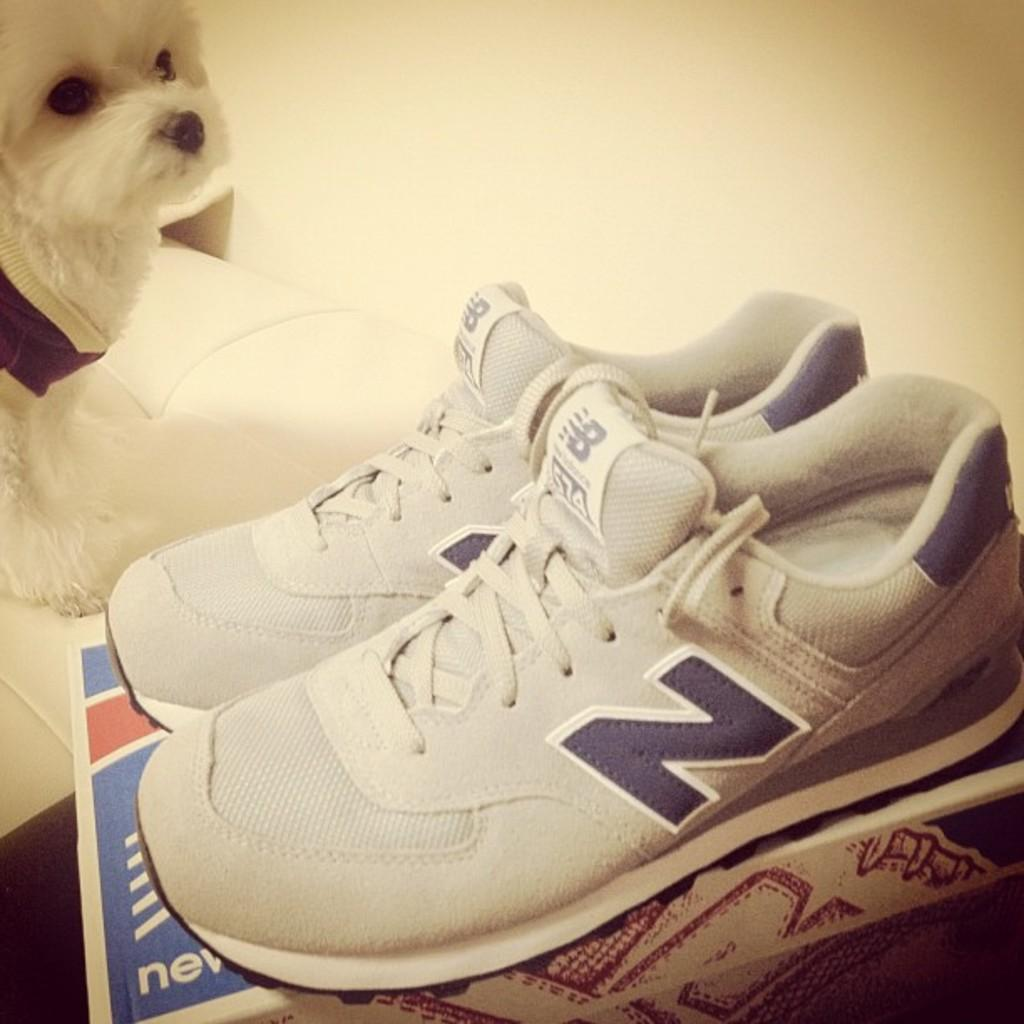What type of object is in the image? There is a pair of shoes in the image. What else can be seen in the image? There is a dog on the bed in the image. What is visible in the background of the image? There is a wall in the background of the image. What type of food is the dog eating in the image? There is no food present in the image, and the dog is not shown eating anything. 